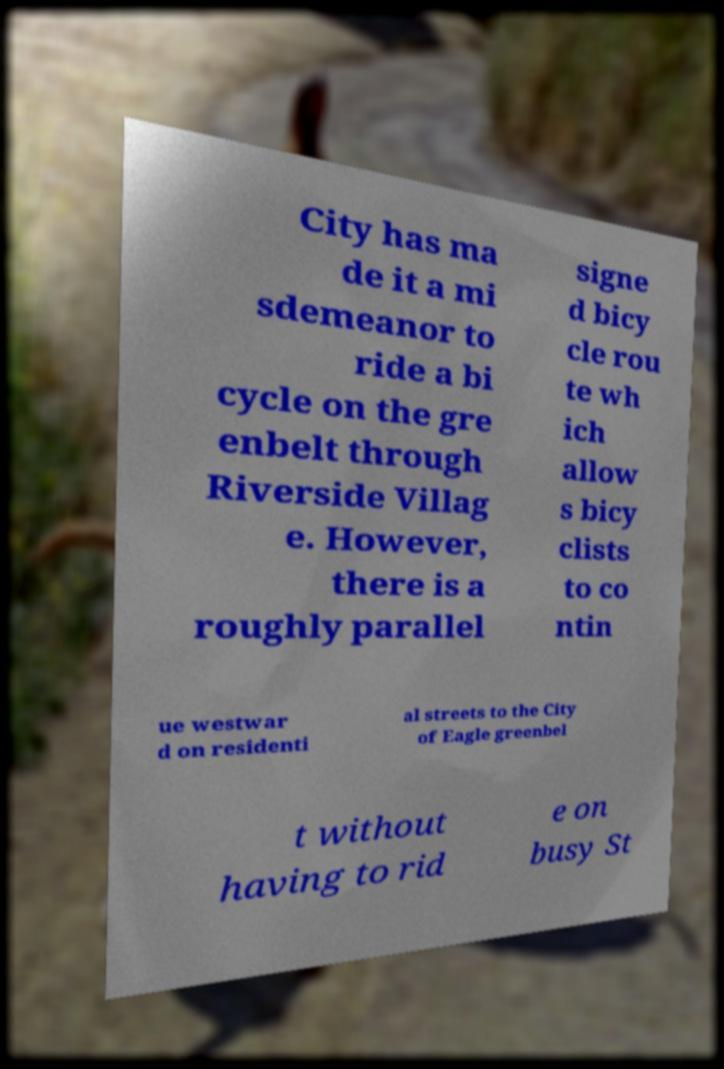Could you extract and type out the text from this image? City has ma de it a mi sdemeanor to ride a bi cycle on the gre enbelt through Riverside Villag e. However, there is a roughly parallel signe d bicy cle rou te wh ich allow s bicy clists to co ntin ue westwar d on residenti al streets to the City of Eagle greenbel t without having to rid e on busy St 